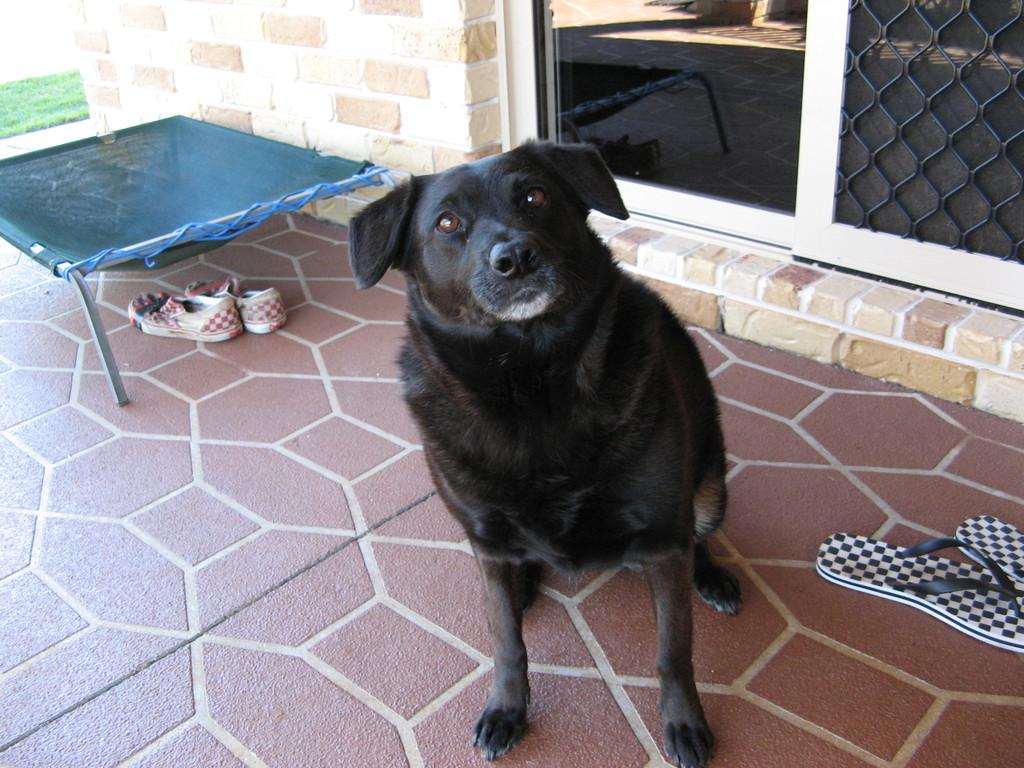What is the main subject in the middle of the image? There is a dog in the middle of the image. What can be seen on the right side of the image? There are glass windows on the right side of the image, and a chapel is visible through them. What is located on the left side of the image? There is a net on the left side of the image. What items are near the net? Shoes are present near the net. Can you tell me how many owls are sitting on the net in the image? There are no owls present in the image; it features a dog, glass windows, a chapel, a net, and shoes. What type of shop is visible through the glass windows? There is no shop visible through the glass windows; it is a chapel. 